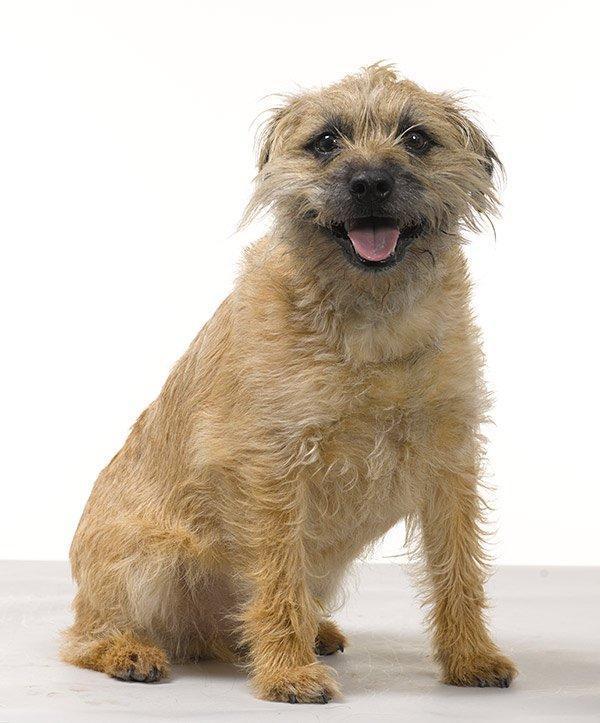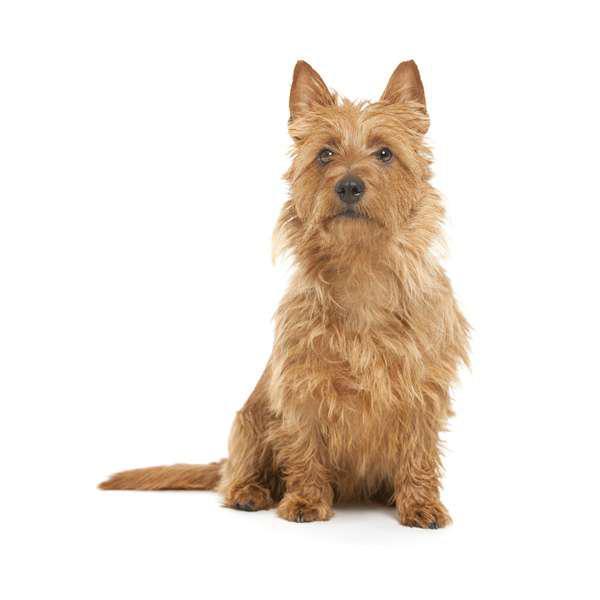The first image is the image on the left, the second image is the image on the right. Considering the images on both sides, is "The left and right image contains the same number of dogs with at least one of them sitting." valid? Answer yes or no. Yes. The first image is the image on the left, the second image is the image on the right. Assess this claim about the two images: "A dog is laying down.". Correct or not? Answer yes or no. No. 